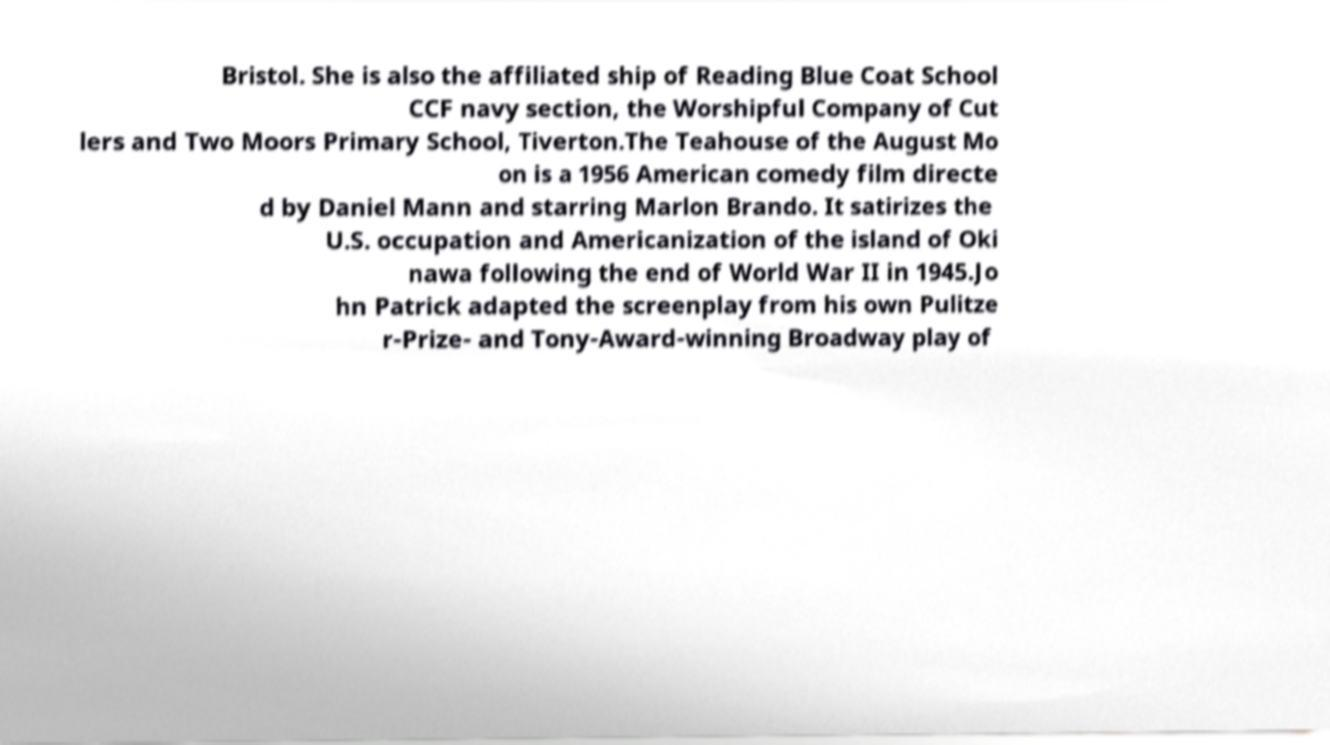For documentation purposes, I need the text within this image transcribed. Could you provide that? Bristol. She is also the affiliated ship of Reading Blue Coat School CCF navy section, the Worshipful Company of Cut lers and Two Moors Primary School, Tiverton.The Teahouse of the August Mo on is a 1956 American comedy film directe d by Daniel Mann and starring Marlon Brando. It satirizes the U.S. occupation and Americanization of the island of Oki nawa following the end of World War II in 1945.Jo hn Patrick adapted the screenplay from his own Pulitze r-Prize- and Tony-Award-winning Broadway play of 